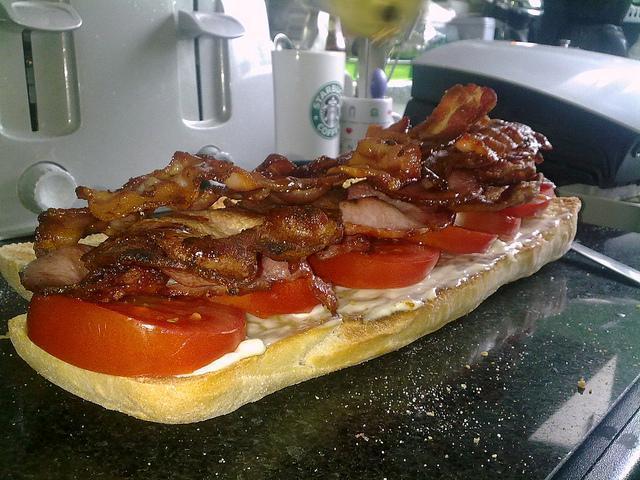What is missing to make a classic sandwich?
Indicate the correct response by choosing from the four available options to answer the question.
Options: Mustard, pickles, onions, lettuce. Lettuce. 